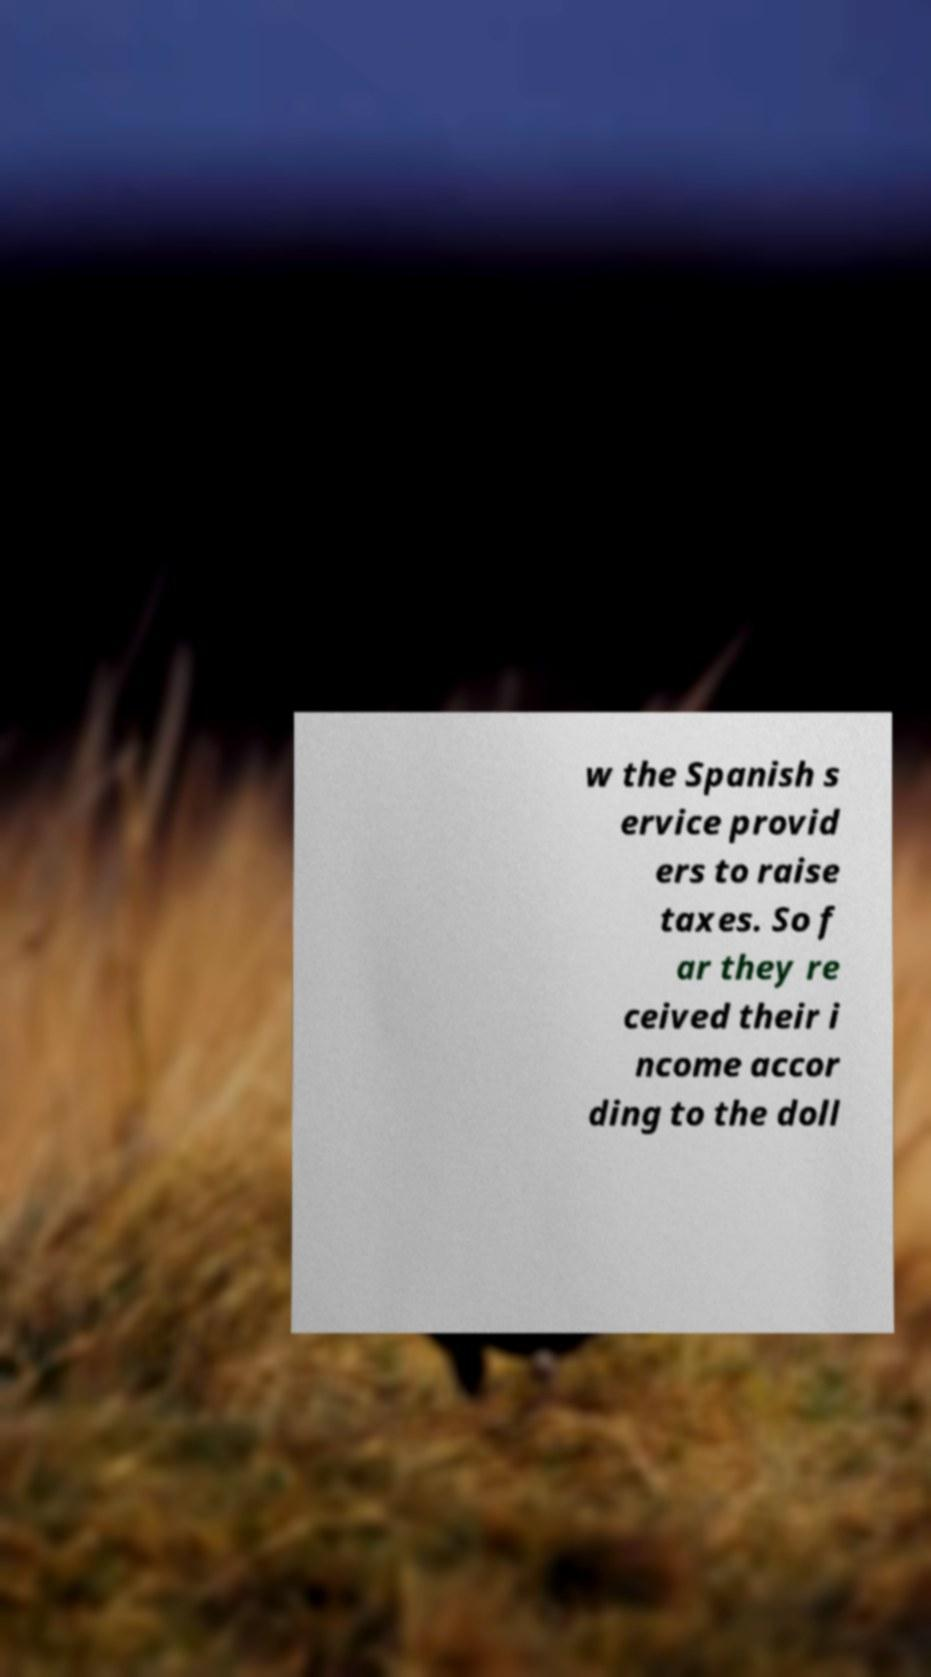Please identify and transcribe the text found in this image. w the Spanish s ervice provid ers to raise taxes. So f ar they re ceived their i ncome accor ding to the doll 